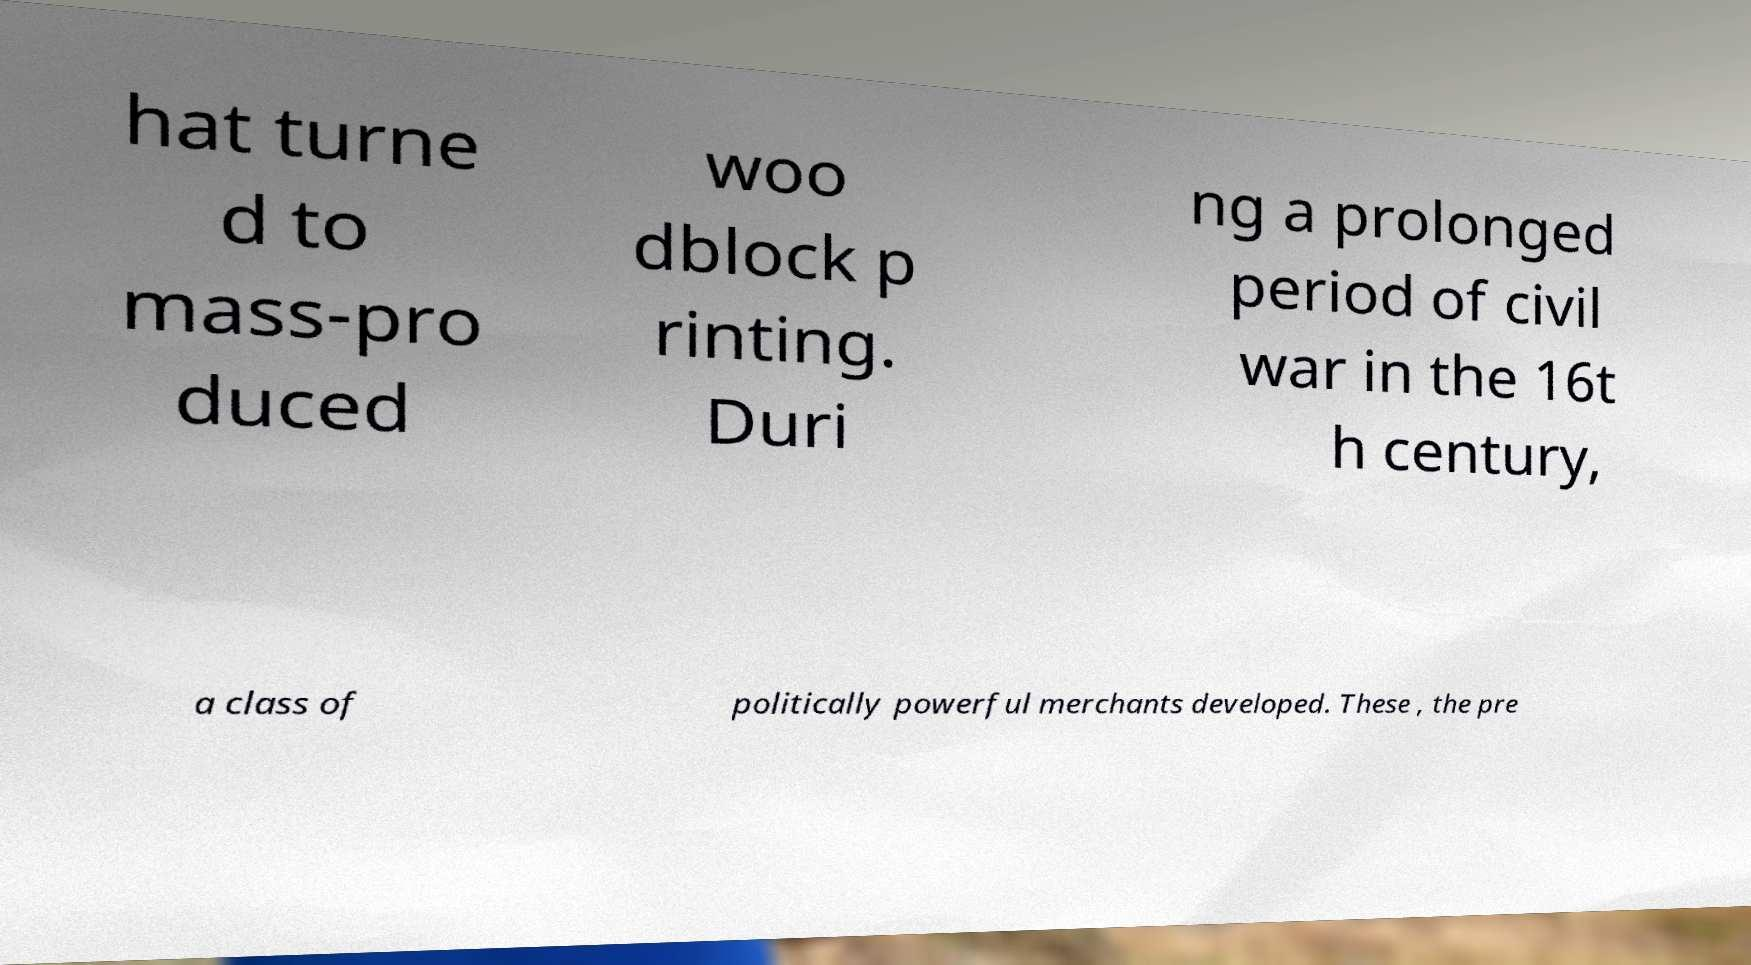I need the written content from this picture converted into text. Can you do that? hat turne d to mass-pro duced woo dblock p rinting. Duri ng a prolonged period of civil war in the 16t h century, a class of politically powerful merchants developed. These , the pre 